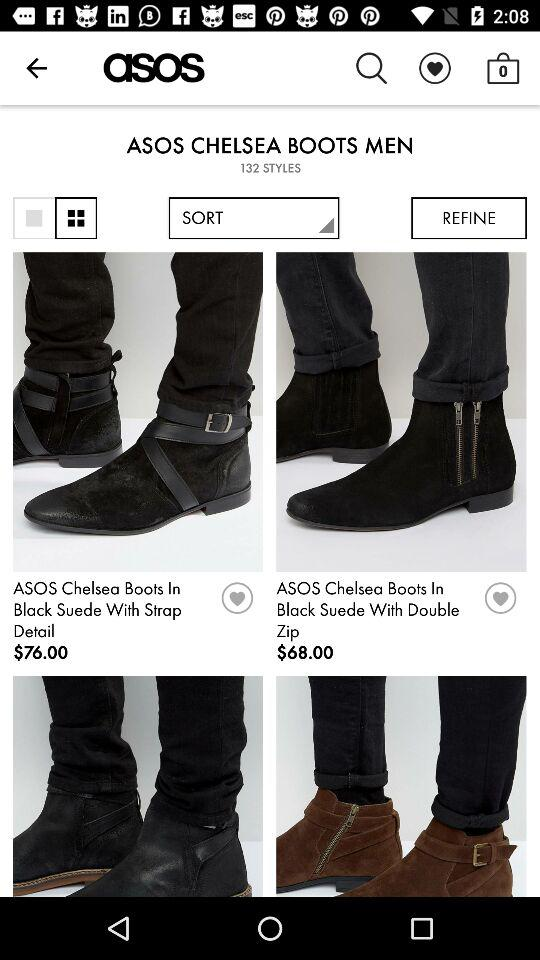How much is the price of "ASOS Chelsea Boots In Black Suede With Strap Detail"? The price of "ASOS Chelsea Boots In Black Suede With Strap Detail" is $76. 